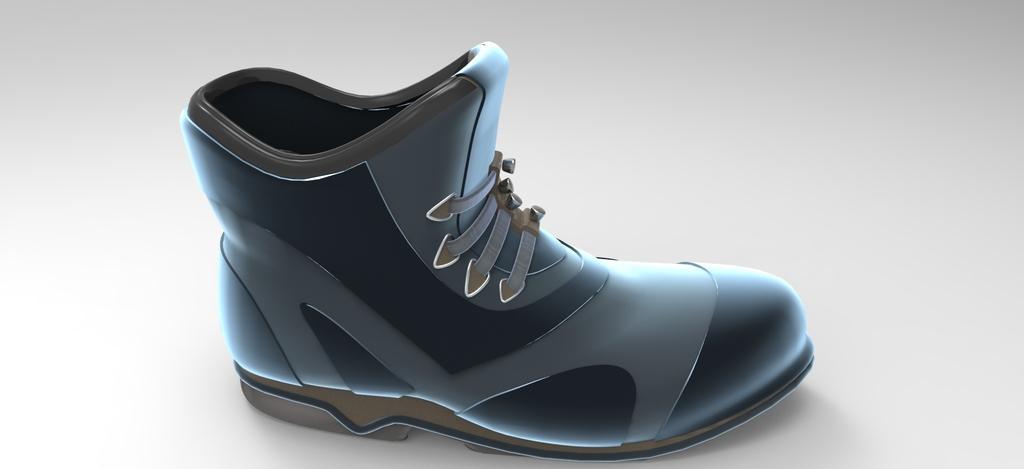In one or two sentences, can you explain what this image depicts? In this image we can see an animated picture of a shoe. 